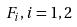<formula> <loc_0><loc_0><loc_500><loc_500>F _ { i } , i = 1 , 2</formula> 